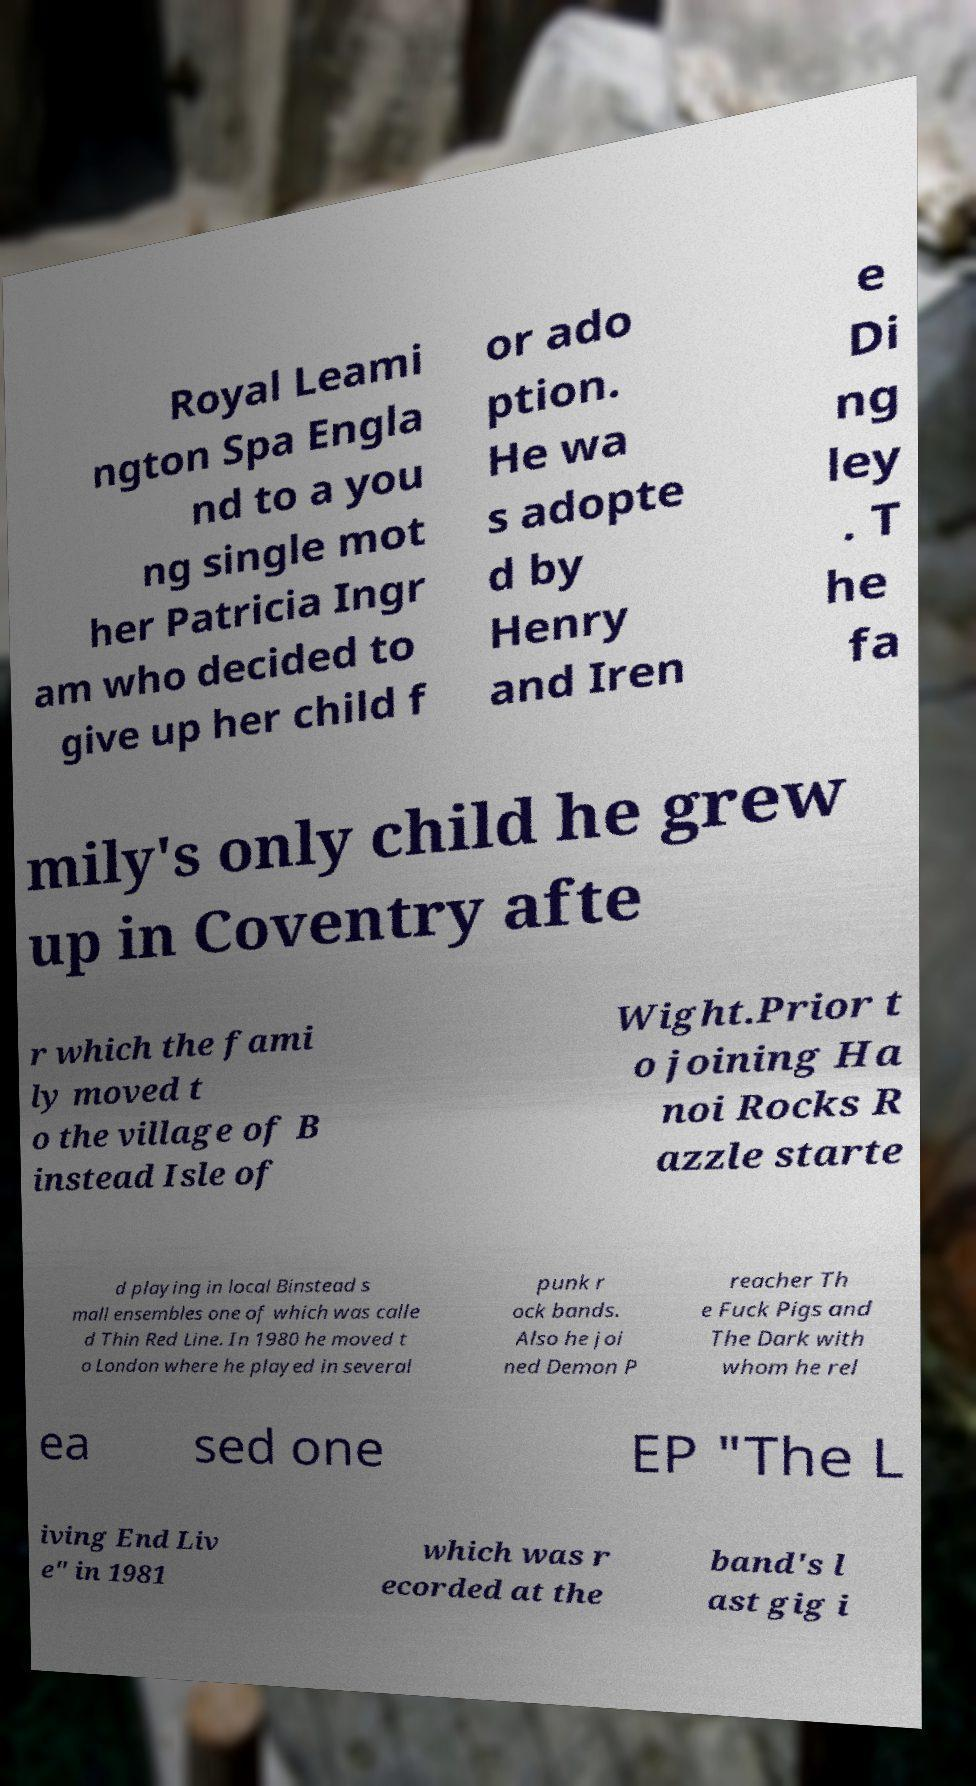Could you extract and type out the text from this image? Royal Leami ngton Spa Engla nd to a you ng single mot her Patricia Ingr am who decided to give up her child f or ado ption. He wa s adopte d by Henry and Iren e Di ng ley . T he fa mily's only child he grew up in Coventry afte r which the fami ly moved t o the village of B instead Isle of Wight.Prior t o joining Ha noi Rocks R azzle starte d playing in local Binstead s mall ensembles one of which was calle d Thin Red Line. In 1980 he moved t o London where he played in several punk r ock bands. Also he joi ned Demon P reacher Th e Fuck Pigs and The Dark with whom he rel ea sed one EP "The L iving End Liv e" in 1981 which was r ecorded at the band's l ast gig i 